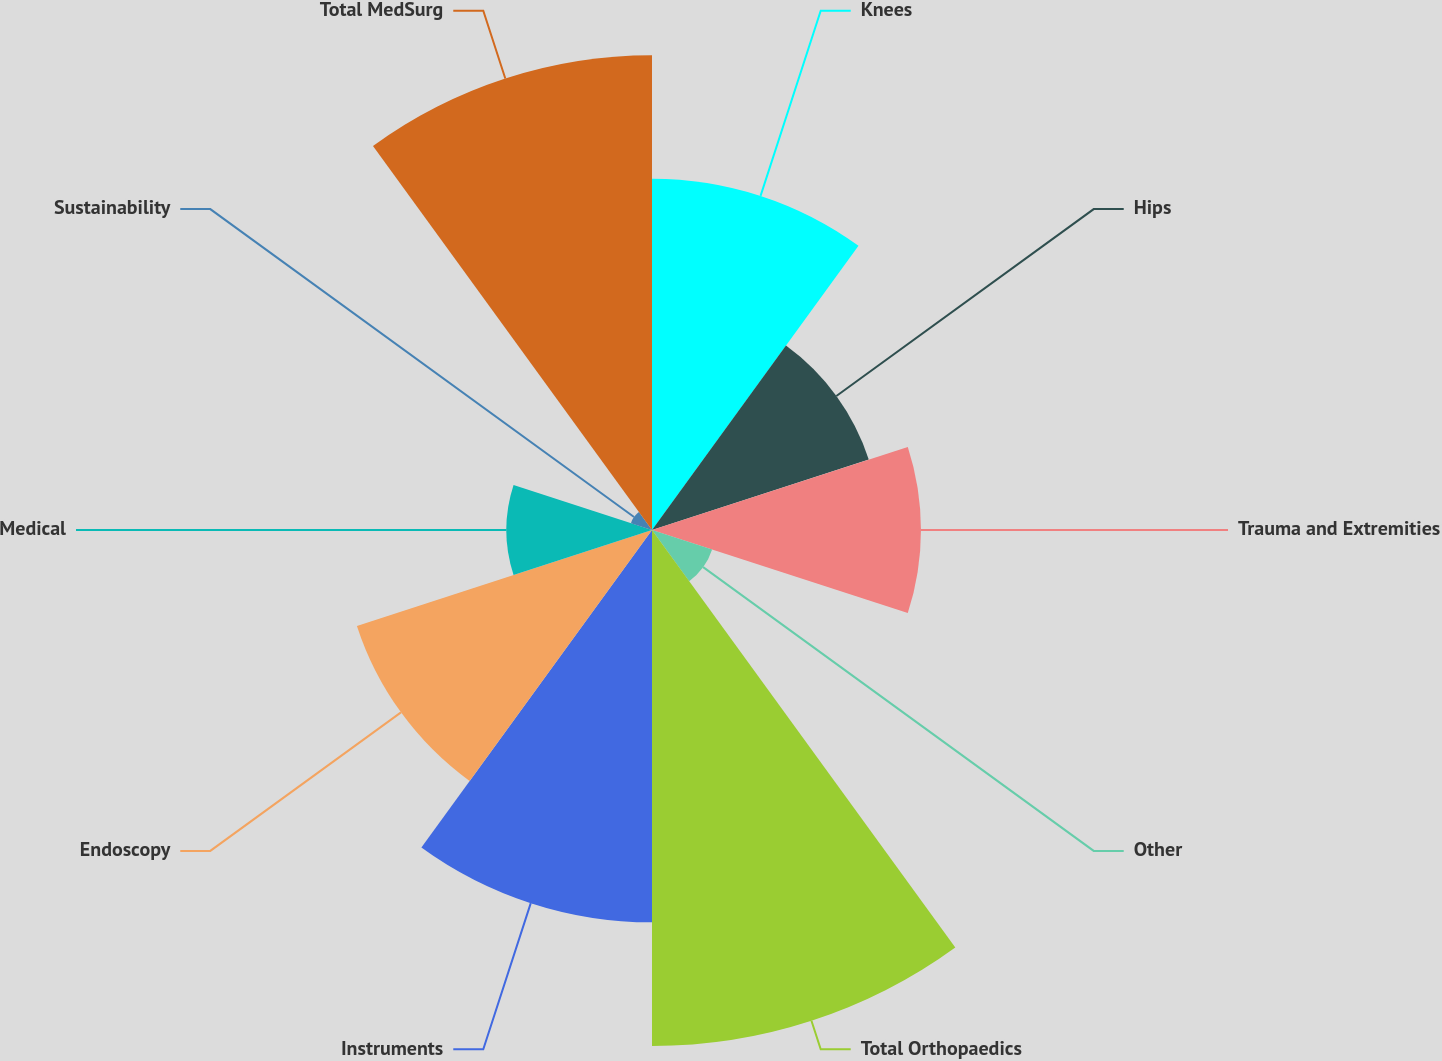Convert chart. <chart><loc_0><loc_0><loc_500><loc_500><pie_chart><fcel>Knees<fcel>Hips<fcel>Trauma and Extremities<fcel>Other<fcel>Total Orthopaedics<fcel>Instruments<fcel>Endoscopy<fcel>Medical<fcel>Sustainability<fcel>Total MedSurg<nl><fcel>12.67%<fcel>8.22%<fcel>9.7%<fcel>2.28%<fcel>18.61%<fcel>14.15%<fcel>11.19%<fcel>5.25%<fcel>0.8%<fcel>17.12%<nl></chart> 